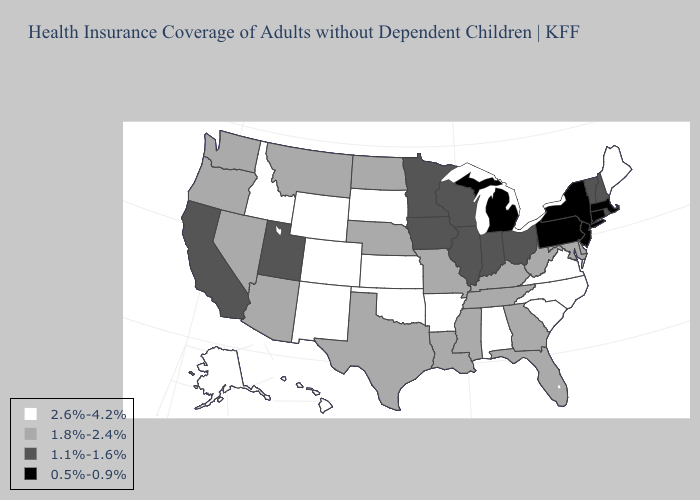What is the value of California?
Write a very short answer. 1.1%-1.6%. Name the states that have a value in the range 0.5%-0.9%?
Be succinct. Connecticut, Massachusetts, Michigan, New Jersey, New York, Pennsylvania. Which states have the highest value in the USA?
Write a very short answer. Alabama, Alaska, Arkansas, Colorado, Hawaii, Idaho, Kansas, Maine, New Mexico, North Carolina, Oklahoma, South Carolina, South Dakota, Virginia, Wyoming. Does Virginia have the highest value in the USA?
Short answer required. Yes. Name the states that have a value in the range 1.8%-2.4%?
Answer briefly. Arizona, Delaware, Florida, Georgia, Kentucky, Louisiana, Maryland, Mississippi, Missouri, Montana, Nebraska, Nevada, North Dakota, Oregon, Tennessee, Texas, Washington, West Virginia. What is the value of South Dakota?
Concise answer only. 2.6%-4.2%. What is the value of New Hampshire?
Be succinct. 1.1%-1.6%. Name the states that have a value in the range 1.8%-2.4%?
Answer briefly. Arizona, Delaware, Florida, Georgia, Kentucky, Louisiana, Maryland, Mississippi, Missouri, Montana, Nebraska, Nevada, North Dakota, Oregon, Tennessee, Texas, Washington, West Virginia. Which states have the lowest value in the USA?
Be succinct. Connecticut, Massachusetts, Michigan, New Jersey, New York, Pennsylvania. Does Iowa have the highest value in the USA?
Give a very brief answer. No. Name the states that have a value in the range 2.6%-4.2%?
Concise answer only. Alabama, Alaska, Arkansas, Colorado, Hawaii, Idaho, Kansas, Maine, New Mexico, North Carolina, Oklahoma, South Carolina, South Dakota, Virginia, Wyoming. Among the states that border South Carolina , which have the highest value?
Concise answer only. North Carolina. What is the value of Indiana?
Concise answer only. 1.1%-1.6%. What is the value of Wyoming?
Quick response, please. 2.6%-4.2%. Does South Carolina have a higher value than Oregon?
Write a very short answer. Yes. 